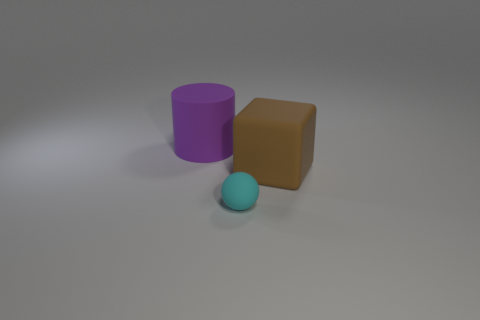Add 1 cyan matte balls. How many objects exist? 4 Subtract 1 cyan spheres. How many objects are left? 2 Subtract all spheres. How many objects are left? 2 Subtract all cyan rubber cubes. Subtract all purple rubber cylinders. How many objects are left? 2 Add 1 purple objects. How many purple objects are left? 2 Add 1 tiny blue balls. How many tiny blue balls exist? 1 